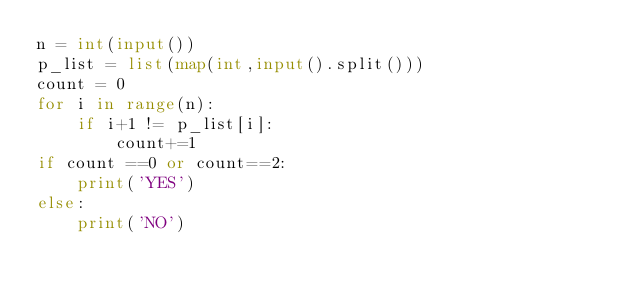<code> <loc_0><loc_0><loc_500><loc_500><_Python_>n = int(input())
p_list = list(map(int,input().split()))
count = 0
for i in range(n):
    if i+1 != p_list[i]:
        count+=1
if count ==0 or count==2:
    print('YES')
else:
    print('NO')</code> 